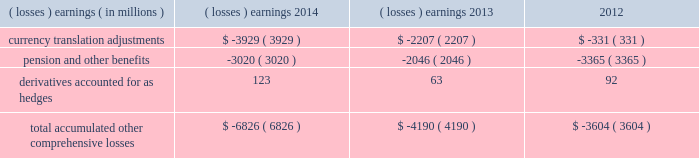Note 17 .
Accumulated other comprehensive losses : pmi's accumulated other comprehensive losses , net of taxes , consisted of the following: .
Reclassifications from other comprehensive earnings the movements in accumulated other comprehensive losses and the related tax impact , for each of the components above , that are due to current period activity and reclassifications to the income statement are shown on the consolidated statements of comprehensive earnings for the years ended december 31 , 2014 , 2013 , and 2012 .
The movement in currency translation adjustments for the year ended december 31 , 2013 , was also impacted by the purchase of the remaining shares of the mexican tobacco business .
In addition , $ 5 million and $ 12 million of net currency translation adjustment gains were transferred from other comprehensive earnings to marketing , administration and research costs in the consolidated statements of earnings for the years ended december 31 , 2014 and 2013 , respectively , upon liquidation of a subsidiary .
For additional information , see note 13 .
Benefit plans and note 15 .
Financial instruments for disclosures related to pmi's pension and other benefits and derivative financial instruments .
Note 18 .
Colombian investment and cooperation agreement : on june 19 , 2009 , pmi announced that it had signed an agreement with the republic of colombia , together with the departments of colombia and the capital district of bogota , to promote investment and cooperation with respect to the colombian tobacco market and to fight counterfeit and contraband tobacco products .
The investment and cooperation agreement provides $ 200 million in funding to the colombian governments over a 20-year period to address issues of mutual interest , such as combating the illegal cigarette trade , including the threat of counterfeit tobacco products , and increasing the quality and quantity of locally grown tobacco .
As a result of the investment and cooperation agreement , pmi recorded a pre-tax charge of $ 135 million in the operating results of the latin america & canada segment during the second quarter of 2009 .
At december 31 , 2014 and 2013 , pmi had $ 71 million and $ 74 million , respectively , of discounted liabilities associated with the colombian investment and cooperation agreement .
These discounted liabilities are primarily reflected in other long-term liabilities on the consolidated balance sheets and are expected to be paid through 2028 .
Note 19 .
Rbh legal settlement : on july 31 , 2008 , rothmans inc .
( "rothmans" ) announced the finalization of a cad 550 million settlement ( or approximately $ 540 million , based on the prevailing exchange rate at that time ) between itself and rothmans , benson & hedges inc .
( "rbh" ) , on the one hand , and the government of canada and all 10 provinces , on the other hand .
The settlement resolved the royal canadian mounted police's investigation relating to products exported from canada by rbh during the 1989-1996 period .
Rothmans' sole holding was a 60% ( 60 % ) interest in rbh .
The remaining 40% ( 40 % ) interest in rbh was owned by pmi. .
What was the change in total accumulated other comprehensive losses in millions from 2012 to 2013? 
Computations: (-4190 - -3604)
Answer: -586.0. 